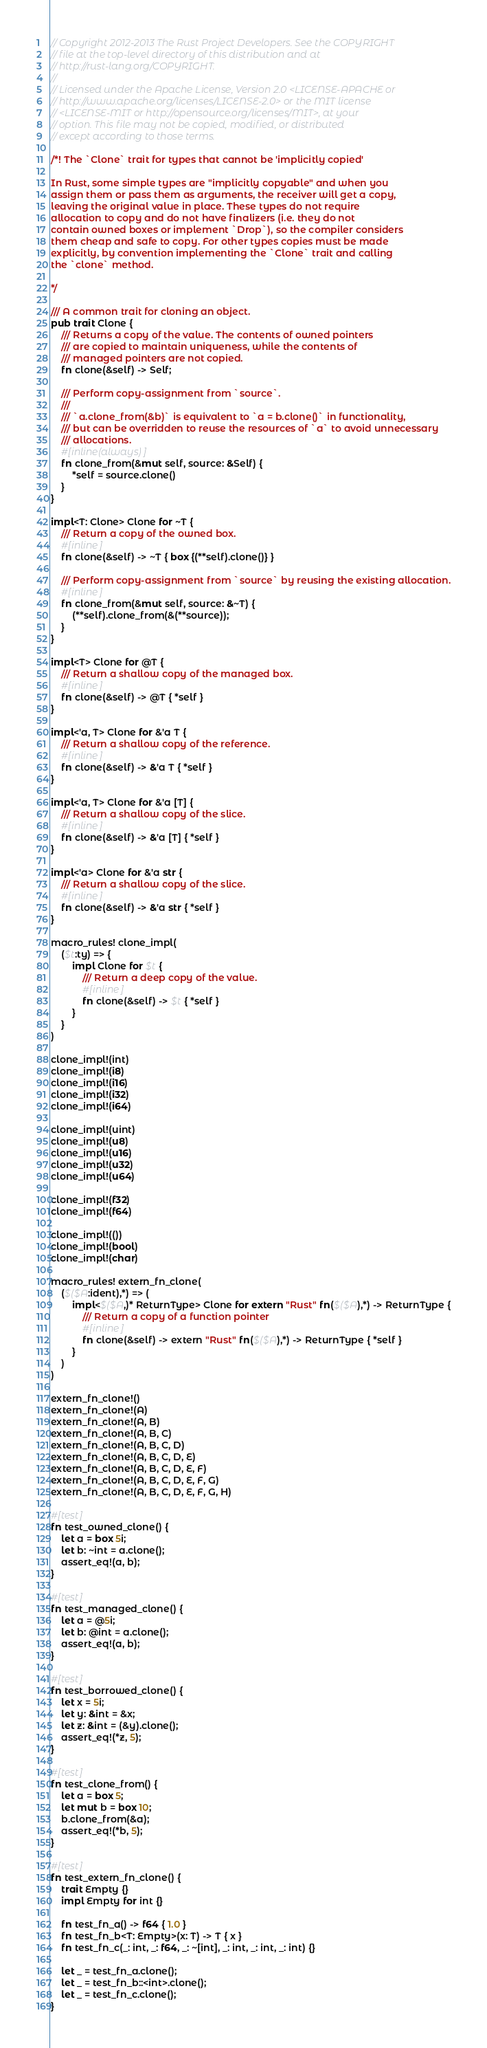Convert code to text. <code><loc_0><loc_0><loc_500><loc_500><_Rust_>// Copyright 2012-2013 The Rust Project Developers. See the COPYRIGHT
// file at the top-level directory of this distribution and at
// http://rust-lang.org/COPYRIGHT.
//
// Licensed under the Apache License, Version 2.0 <LICENSE-APACHE or
// http://www.apache.org/licenses/LICENSE-2.0> or the MIT license
// <LICENSE-MIT or http://opensource.org/licenses/MIT>, at your
// option. This file may not be copied, modified, or distributed
// except according to those terms.

/*! The `Clone` trait for types that cannot be 'implicitly copied'

In Rust, some simple types are "implicitly copyable" and when you
assign them or pass them as arguments, the receiver will get a copy,
leaving the original value in place. These types do not require
allocation to copy and do not have finalizers (i.e. they do not
contain owned boxes or implement `Drop`), so the compiler considers
them cheap and safe to copy. For other types copies must be made
explicitly, by convention implementing the `Clone` trait and calling
the `clone` method.

*/

/// A common trait for cloning an object.
pub trait Clone {
    /// Returns a copy of the value. The contents of owned pointers
    /// are copied to maintain uniqueness, while the contents of
    /// managed pointers are not copied.
    fn clone(&self) -> Self;

    /// Perform copy-assignment from `source`.
    ///
    /// `a.clone_from(&b)` is equivalent to `a = b.clone()` in functionality,
    /// but can be overridden to reuse the resources of `a` to avoid unnecessary
    /// allocations.
    #[inline(always)]
    fn clone_from(&mut self, source: &Self) {
        *self = source.clone()
    }
}

impl<T: Clone> Clone for ~T {
    /// Return a copy of the owned box.
    #[inline]
    fn clone(&self) -> ~T { box {(**self).clone()} }

    /// Perform copy-assignment from `source` by reusing the existing allocation.
    #[inline]
    fn clone_from(&mut self, source: &~T) {
        (**self).clone_from(&(**source));
    }
}

impl<T> Clone for @T {
    /// Return a shallow copy of the managed box.
    #[inline]
    fn clone(&self) -> @T { *self }
}

impl<'a, T> Clone for &'a T {
    /// Return a shallow copy of the reference.
    #[inline]
    fn clone(&self) -> &'a T { *self }
}

impl<'a, T> Clone for &'a [T] {
    /// Return a shallow copy of the slice.
    #[inline]
    fn clone(&self) -> &'a [T] { *self }
}

impl<'a> Clone for &'a str {
    /// Return a shallow copy of the slice.
    #[inline]
    fn clone(&self) -> &'a str { *self }
}

macro_rules! clone_impl(
    ($t:ty) => {
        impl Clone for $t {
            /// Return a deep copy of the value.
            #[inline]
            fn clone(&self) -> $t { *self }
        }
    }
)

clone_impl!(int)
clone_impl!(i8)
clone_impl!(i16)
clone_impl!(i32)
clone_impl!(i64)

clone_impl!(uint)
clone_impl!(u8)
clone_impl!(u16)
clone_impl!(u32)
clone_impl!(u64)

clone_impl!(f32)
clone_impl!(f64)

clone_impl!(())
clone_impl!(bool)
clone_impl!(char)

macro_rules! extern_fn_clone(
    ($($A:ident),*) => (
        impl<$($A,)* ReturnType> Clone for extern "Rust" fn($($A),*) -> ReturnType {
            /// Return a copy of a function pointer
            #[inline]
            fn clone(&self) -> extern "Rust" fn($($A),*) -> ReturnType { *self }
        }
    )
)

extern_fn_clone!()
extern_fn_clone!(A)
extern_fn_clone!(A, B)
extern_fn_clone!(A, B, C)
extern_fn_clone!(A, B, C, D)
extern_fn_clone!(A, B, C, D, E)
extern_fn_clone!(A, B, C, D, E, F)
extern_fn_clone!(A, B, C, D, E, F, G)
extern_fn_clone!(A, B, C, D, E, F, G, H)

#[test]
fn test_owned_clone() {
    let a = box 5i;
    let b: ~int = a.clone();
    assert_eq!(a, b);
}

#[test]
fn test_managed_clone() {
    let a = @5i;
    let b: @int = a.clone();
    assert_eq!(a, b);
}

#[test]
fn test_borrowed_clone() {
    let x = 5i;
    let y: &int = &x;
    let z: &int = (&y).clone();
    assert_eq!(*z, 5);
}

#[test]
fn test_clone_from() {
    let a = box 5;
    let mut b = box 10;
    b.clone_from(&a);
    assert_eq!(*b, 5);
}

#[test]
fn test_extern_fn_clone() {
    trait Empty {}
    impl Empty for int {}

    fn test_fn_a() -> f64 { 1.0 }
    fn test_fn_b<T: Empty>(x: T) -> T { x }
    fn test_fn_c(_: int, _: f64, _: ~[int], _: int, _: int, _: int) {}

    let _ = test_fn_a.clone();
    let _ = test_fn_b::<int>.clone();
    let _ = test_fn_c.clone();
}
</code> 